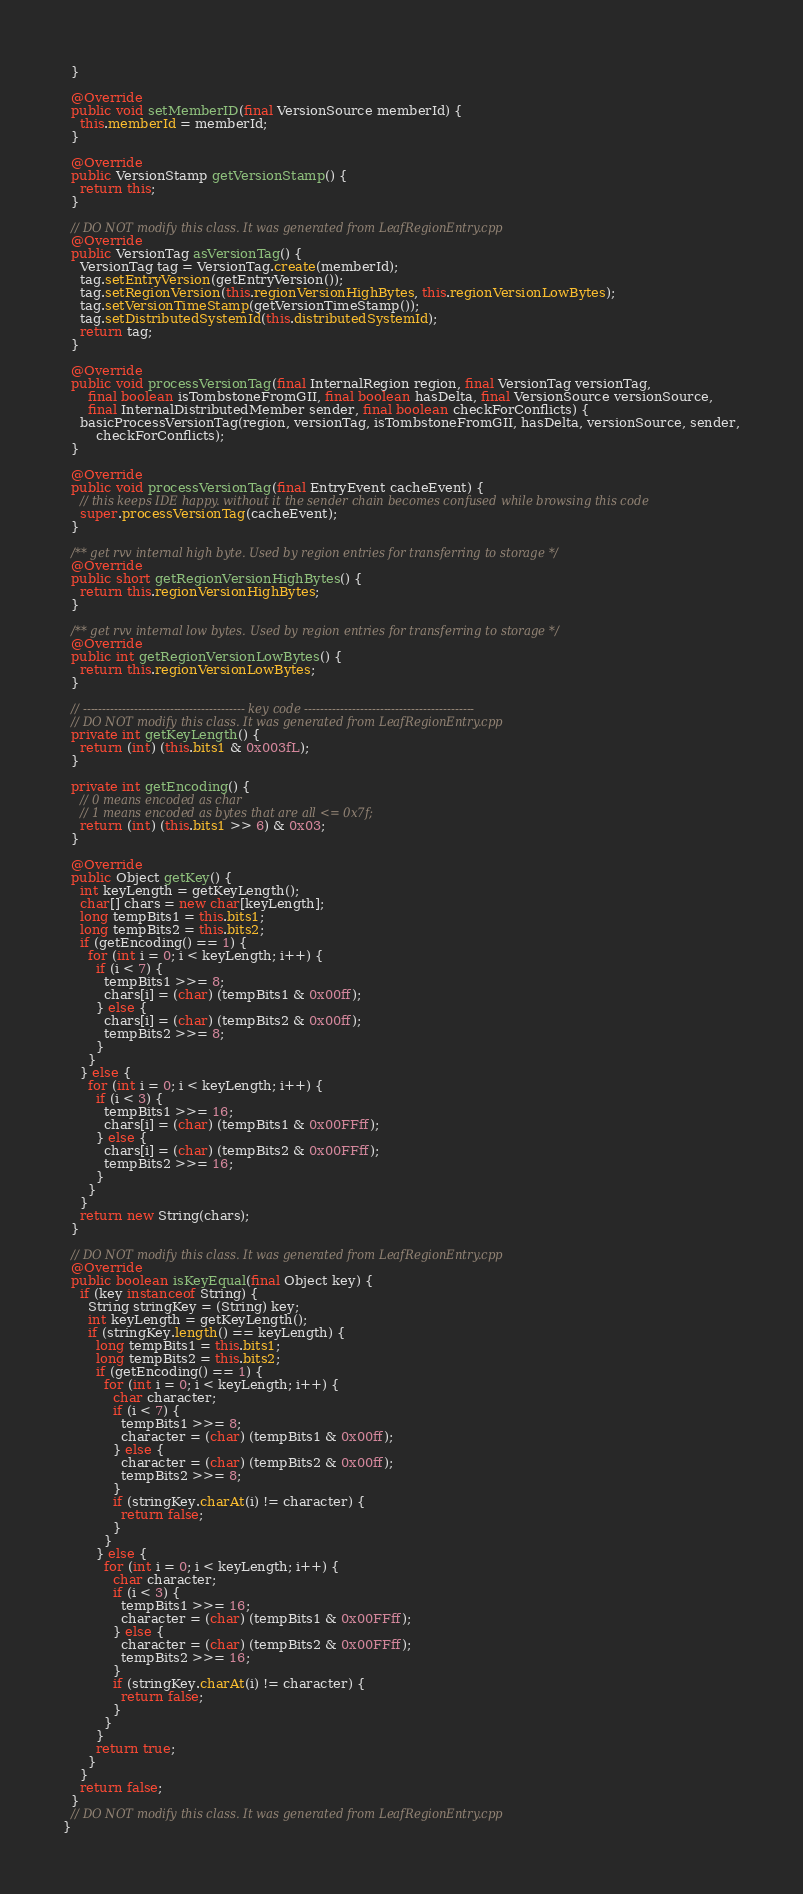<code> <loc_0><loc_0><loc_500><loc_500><_Java_>  }

  @Override
  public void setMemberID(final VersionSource memberId) {
    this.memberId = memberId;
  }

  @Override
  public VersionStamp getVersionStamp() {
    return this;
  }

  // DO NOT modify this class. It was generated from LeafRegionEntry.cpp
  @Override
  public VersionTag asVersionTag() {
    VersionTag tag = VersionTag.create(memberId);
    tag.setEntryVersion(getEntryVersion());
    tag.setRegionVersion(this.regionVersionHighBytes, this.regionVersionLowBytes);
    tag.setVersionTimeStamp(getVersionTimeStamp());
    tag.setDistributedSystemId(this.distributedSystemId);
    return tag;
  }

  @Override
  public void processVersionTag(final InternalRegion region, final VersionTag versionTag,
      final boolean isTombstoneFromGII, final boolean hasDelta, final VersionSource versionSource,
      final InternalDistributedMember sender, final boolean checkForConflicts) {
    basicProcessVersionTag(region, versionTag, isTombstoneFromGII, hasDelta, versionSource, sender,
        checkForConflicts);
  }

  @Override
  public void processVersionTag(final EntryEvent cacheEvent) {
    // this keeps IDE happy. without it the sender chain becomes confused while browsing this code
    super.processVersionTag(cacheEvent);
  }

  /** get rvv internal high byte. Used by region entries for transferring to storage */
  @Override
  public short getRegionVersionHighBytes() {
    return this.regionVersionHighBytes;
  }

  /** get rvv internal low bytes. Used by region entries for transferring to storage */
  @Override
  public int getRegionVersionLowBytes() {
    return this.regionVersionLowBytes;
  }

  // ----------------------------------------- key code -------------------------------------------
  // DO NOT modify this class. It was generated from LeafRegionEntry.cpp
  private int getKeyLength() {
    return (int) (this.bits1 & 0x003fL);
  }

  private int getEncoding() {
    // 0 means encoded as char
    // 1 means encoded as bytes that are all <= 0x7f;
    return (int) (this.bits1 >> 6) & 0x03;
  }

  @Override
  public Object getKey() {
    int keyLength = getKeyLength();
    char[] chars = new char[keyLength];
    long tempBits1 = this.bits1;
    long tempBits2 = this.bits2;
    if (getEncoding() == 1) {
      for (int i = 0; i < keyLength; i++) {
        if (i < 7) {
          tempBits1 >>= 8;
          chars[i] = (char) (tempBits1 & 0x00ff);
        } else {
          chars[i] = (char) (tempBits2 & 0x00ff);
          tempBits2 >>= 8;
        }
      }
    } else {
      for (int i = 0; i < keyLength; i++) {
        if (i < 3) {
          tempBits1 >>= 16;
          chars[i] = (char) (tempBits1 & 0x00FFff);
        } else {
          chars[i] = (char) (tempBits2 & 0x00FFff);
          tempBits2 >>= 16;
        }
      }
    }
    return new String(chars);
  }

  // DO NOT modify this class. It was generated from LeafRegionEntry.cpp
  @Override
  public boolean isKeyEqual(final Object key) {
    if (key instanceof String) {
      String stringKey = (String) key;
      int keyLength = getKeyLength();
      if (stringKey.length() == keyLength) {
        long tempBits1 = this.bits1;
        long tempBits2 = this.bits2;
        if (getEncoding() == 1) {
          for (int i = 0; i < keyLength; i++) {
            char character;
            if (i < 7) {
              tempBits1 >>= 8;
              character = (char) (tempBits1 & 0x00ff);
            } else {
              character = (char) (tempBits2 & 0x00ff);
              tempBits2 >>= 8;
            }
            if (stringKey.charAt(i) != character) {
              return false;
            }
          }
        } else {
          for (int i = 0; i < keyLength; i++) {
            char character;
            if (i < 3) {
              tempBits1 >>= 16;
              character = (char) (tempBits1 & 0x00FFff);
            } else {
              character = (char) (tempBits2 & 0x00FFff);
              tempBits2 >>= 16;
            }
            if (stringKey.charAt(i) != character) {
              return false;
            }
          }
        }
        return true;
      }
    }
    return false;
  }
  // DO NOT modify this class. It was generated from LeafRegionEntry.cpp
}
</code> 